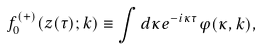<formula> <loc_0><loc_0><loc_500><loc_500>f _ { 0 } ^ { ( + ) } ( z ( \tau ) ; { k } ) \equiv \int d \kappa e ^ { - i \kappa \tau } \varphi ( \kappa , { k } ) ,</formula> 